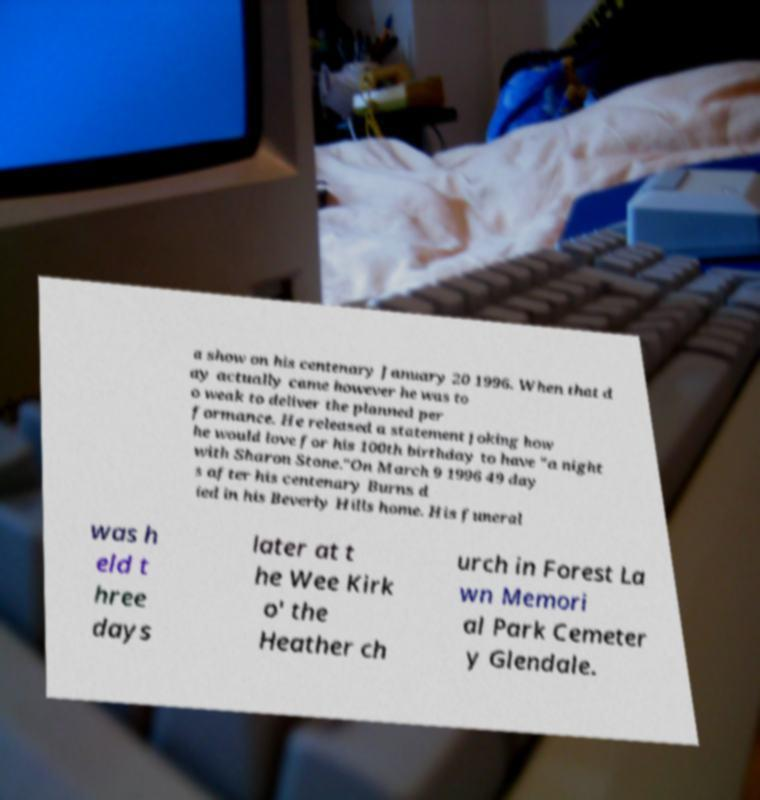Please identify and transcribe the text found in this image. a show on his centenary January 20 1996. When that d ay actually came however he was to o weak to deliver the planned per formance. He released a statement joking how he would love for his 100th birthday to have "a night with Sharon Stone."On March 9 1996 49 day s after his centenary Burns d ied in his Beverly Hills home. His funeral was h eld t hree days later at t he Wee Kirk o' the Heather ch urch in Forest La wn Memori al Park Cemeter y Glendale. 